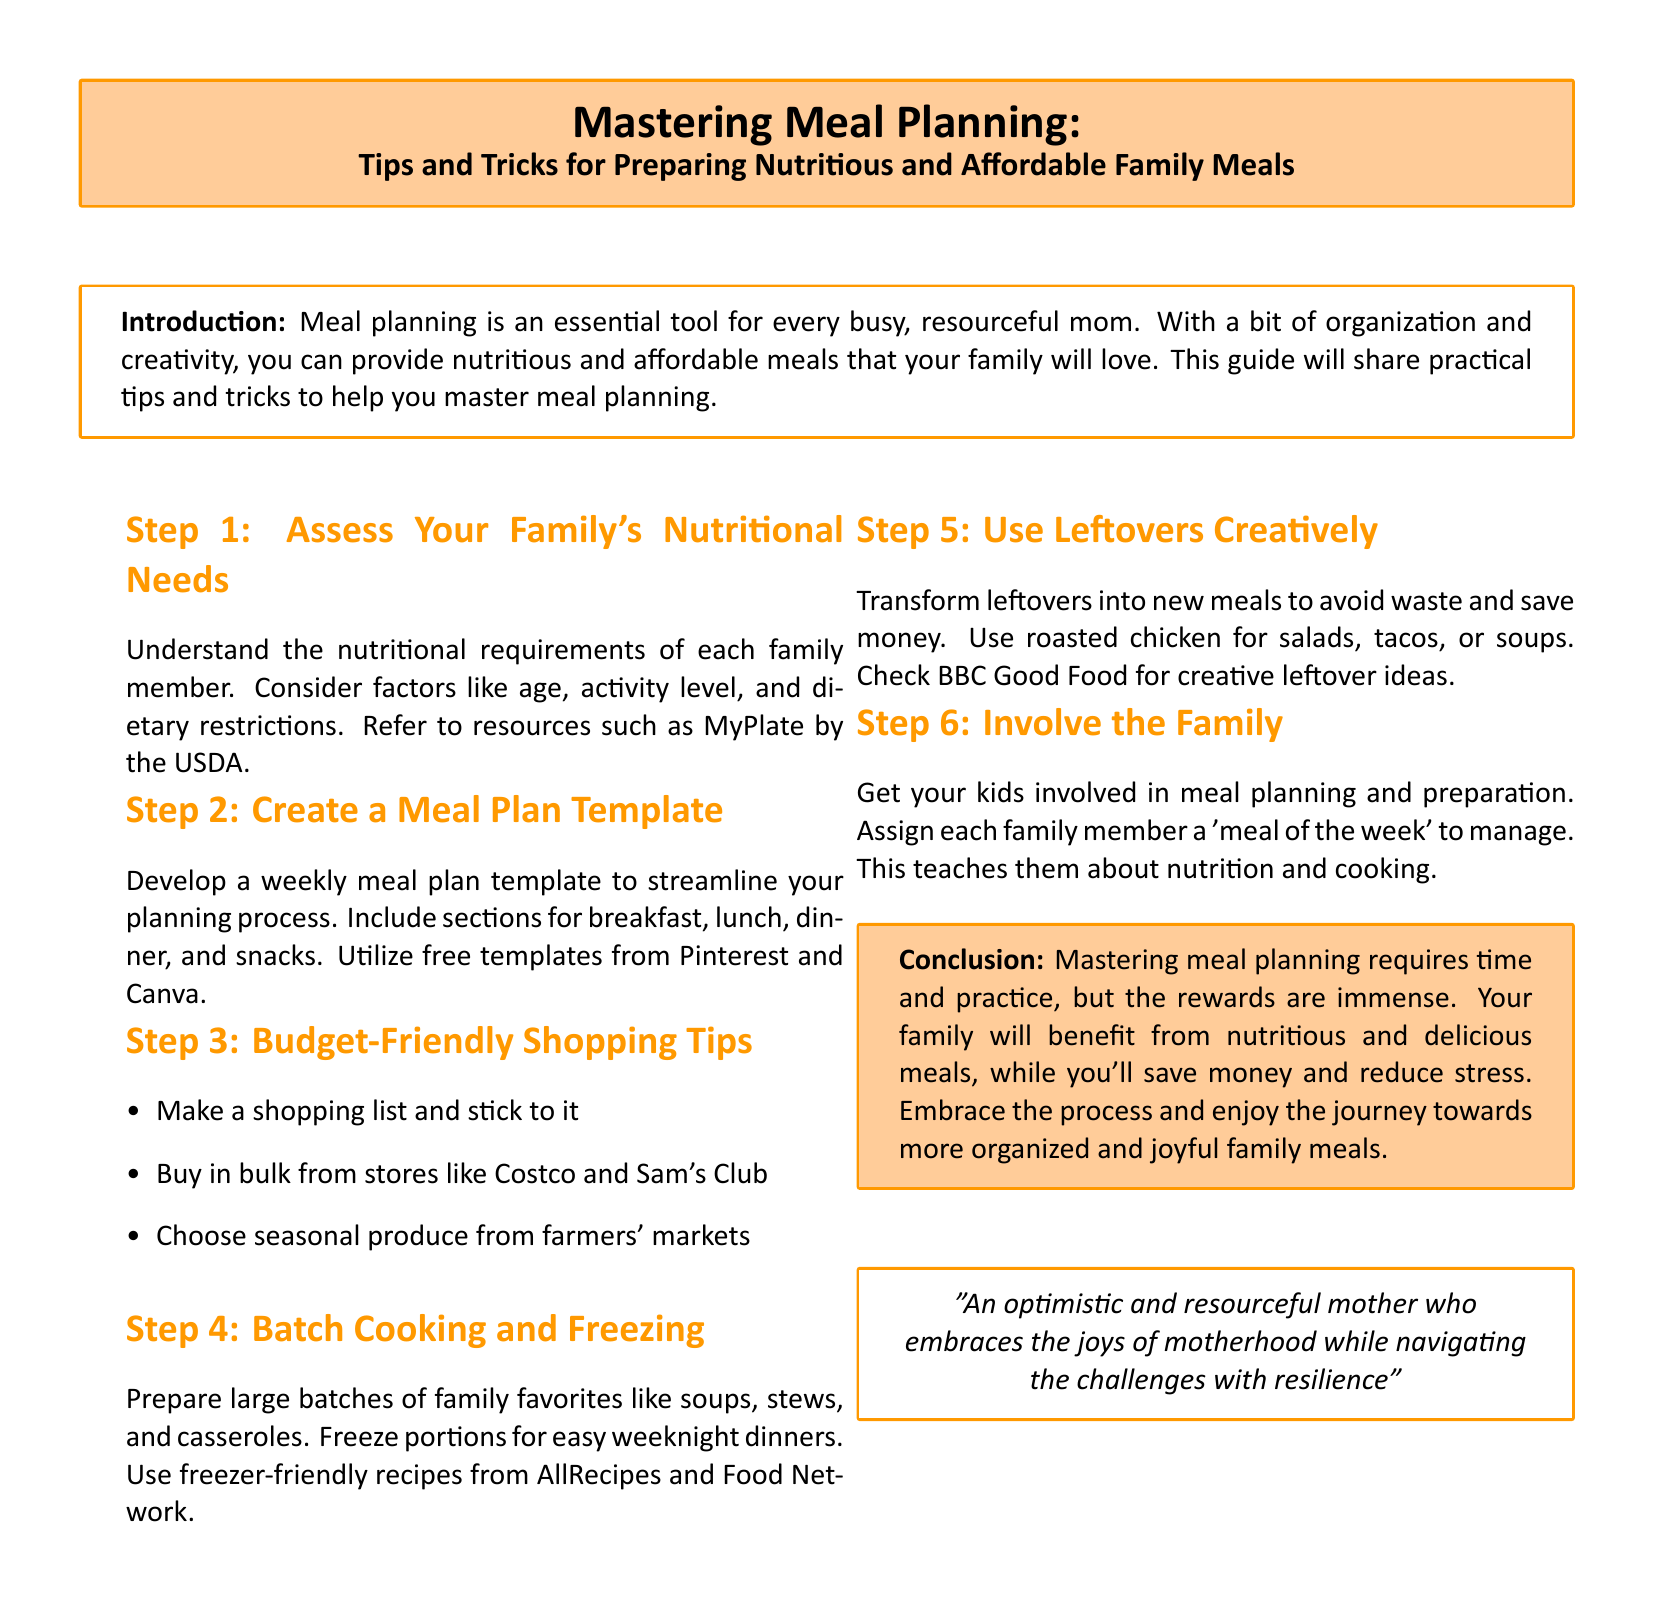what is the main topic of the document? The main topic focuses on meal planning, specifically tips and tricks for preparing family meals that are nutritious and affordable.
Answer: Meal Planning who is the intended audience for the guide? The guide is designed for busy, resourceful moms who are looking to improve their meal planning skills.
Answer: Moms how many steps are outlined in the meal planning process? The document outlines a total of 6 steps to help with meal planning effectively.
Answer: 6 what is recommended to involve the family in meal planning? The guide suggests assigning each family member a "meal of the week" to manage as a way to involve everyone in the process.
Answer: "Meal of the week" what should you do with leftovers according to the guide? The guide recommends transforming leftovers into new meals to avoid waste and save money.
Answer: Use creatively which resources are suggested for finding meal plan templates? The document recommends using free templates from Pinterest and Canva for meal planning.
Answer: Pinterest and Canva what is one key benefit mentioned in the conclusion about mastering meal planning? The conclusion highlights that mastering meal planning leads to reduced stress for the mother.
Answer: Reduced stress what is a suggested shopping tip for staying within budget? One effective tip mentioned is to make a shopping list and stick to it while shopping.
Answer: Shopping list what is the purpose of assessing your family's nutritional needs? Assessing nutritional needs helps understand the dietary restrictions and requirements of each family member.
Answer: Understand requirements 